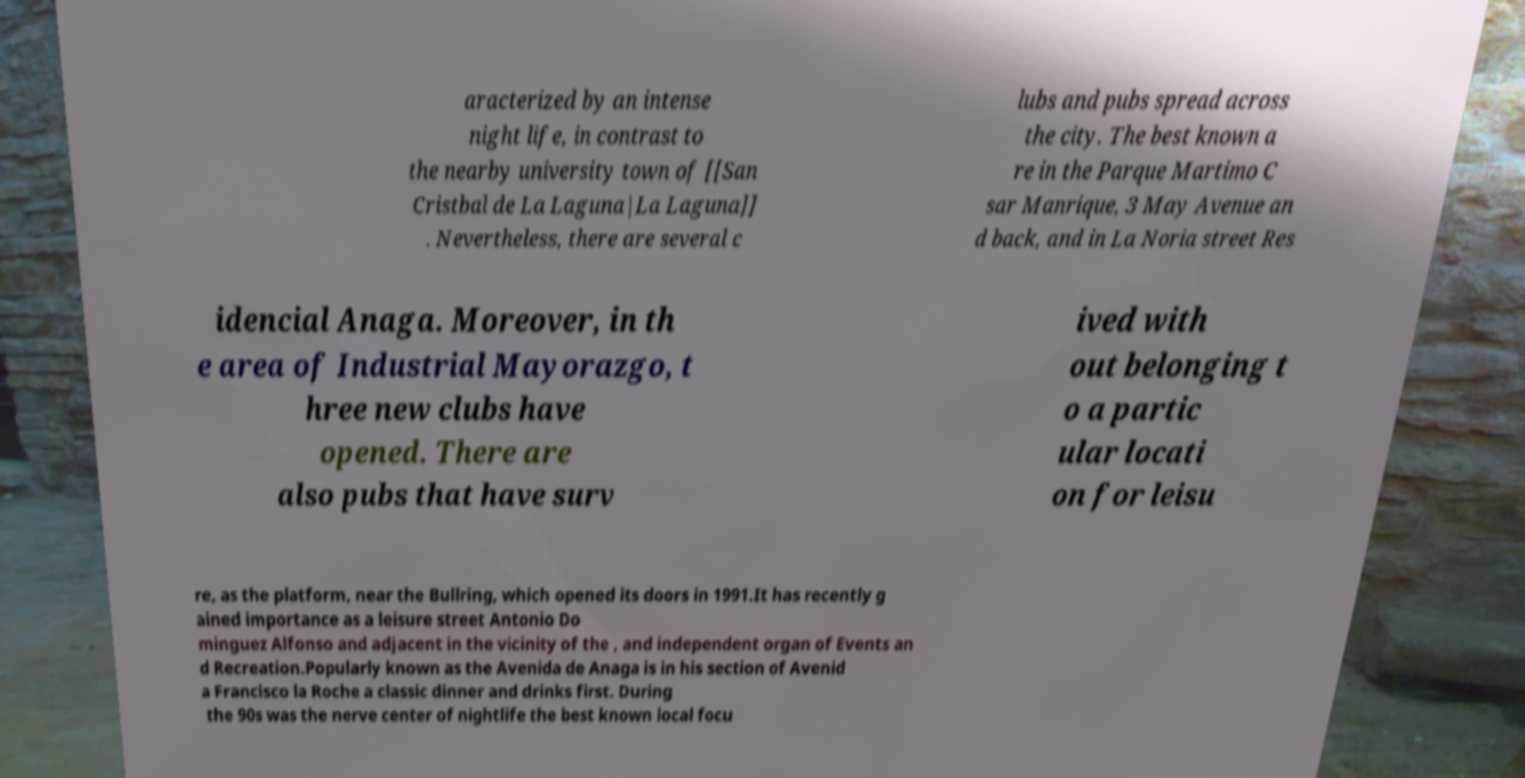What messages or text are displayed in this image? I need them in a readable, typed format. aracterized by an intense night life, in contrast to the nearby university town of [[San Cristbal de La Laguna|La Laguna]] . Nevertheless, there are several c lubs and pubs spread across the city. The best known a re in the Parque Martimo C sar Manrique, 3 May Avenue an d back, and in La Noria street Res idencial Anaga. Moreover, in th e area of Industrial Mayorazgo, t hree new clubs have opened. There are also pubs that have surv ived with out belonging t o a partic ular locati on for leisu re, as the platform, near the Bullring, which opened its doors in 1991.It has recently g ained importance as a leisure street Antonio Do minguez Alfonso and adjacent in the vicinity of the , and independent organ of Events an d Recreation.Popularly known as the Avenida de Anaga is in his section of Avenid a Francisco la Roche a classic dinner and drinks first. During the 90s was the nerve center of nightlife the best known local focu 